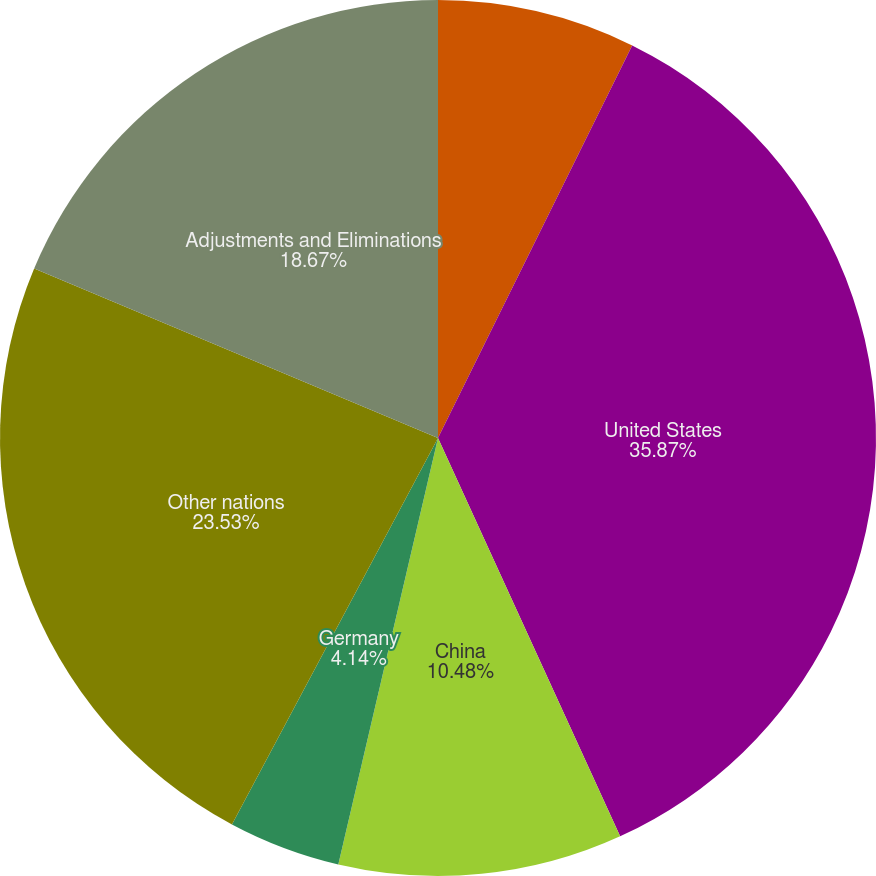<chart> <loc_0><loc_0><loc_500><loc_500><pie_chart><fcel>Years Ended December 31<fcel>United States<fcel>China<fcel>Germany<fcel>Other nations<fcel>Adjustments and Eliminations<nl><fcel>7.31%<fcel>35.86%<fcel>10.48%<fcel>4.14%<fcel>23.53%<fcel>18.67%<nl></chart> 